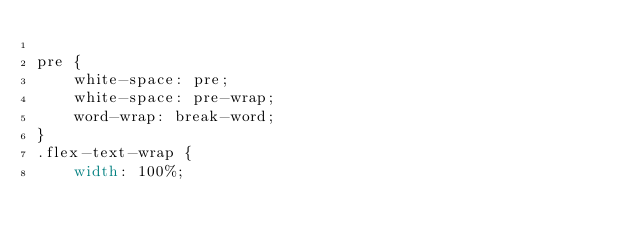Convert code to text. <code><loc_0><loc_0><loc_500><loc_500><_CSS_>
pre {
    white-space: pre;
    white-space: pre-wrap;
    word-wrap: break-word;
}
.flex-text-wrap {
    width: 100%;</code> 